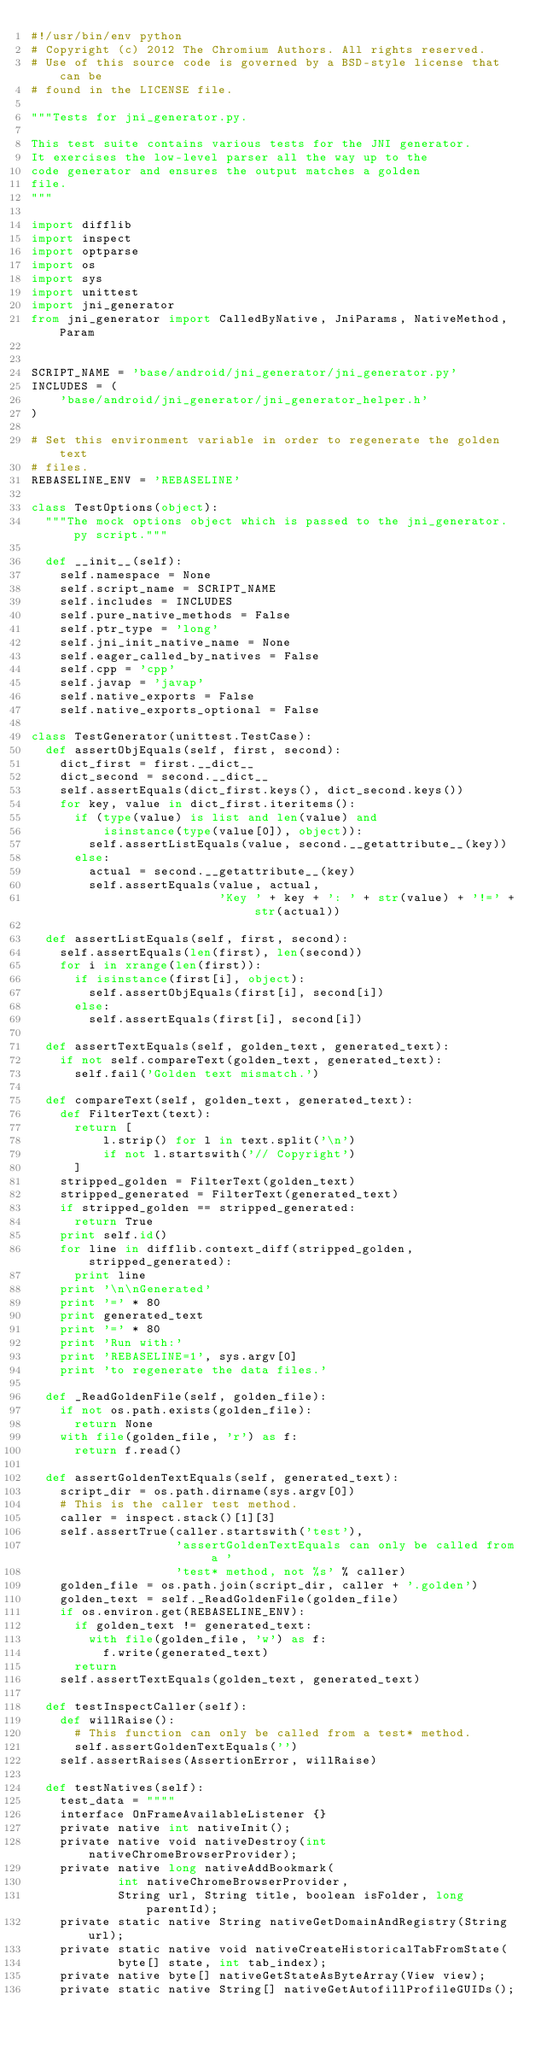Convert code to text. <code><loc_0><loc_0><loc_500><loc_500><_Python_>#!/usr/bin/env python
# Copyright (c) 2012 The Chromium Authors. All rights reserved.
# Use of this source code is governed by a BSD-style license that can be
# found in the LICENSE file.

"""Tests for jni_generator.py.

This test suite contains various tests for the JNI generator.
It exercises the low-level parser all the way up to the
code generator and ensures the output matches a golden
file.
"""

import difflib
import inspect
import optparse
import os
import sys
import unittest
import jni_generator
from jni_generator import CalledByNative, JniParams, NativeMethod, Param


SCRIPT_NAME = 'base/android/jni_generator/jni_generator.py'
INCLUDES = (
    'base/android/jni_generator/jni_generator_helper.h'
)

# Set this environment variable in order to regenerate the golden text
# files.
REBASELINE_ENV = 'REBASELINE'

class TestOptions(object):
  """The mock options object which is passed to the jni_generator.py script."""

  def __init__(self):
    self.namespace = None
    self.script_name = SCRIPT_NAME
    self.includes = INCLUDES
    self.pure_native_methods = False
    self.ptr_type = 'long'
    self.jni_init_native_name = None
    self.eager_called_by_natives = False
    self.cpp = 'cpp'
    self.javap = 'javap'
    self.native_exports = False
    self.native_exports_optional = False

class TestGenerator(unittest.TestCase):
  def assertObjEquals(self, first, second):
    dict_first = first.__dict__
    dict_second = second.__dict__
    self.assertEquals(dict_first.keys(), dict_second.keys())
    for key, value in dict_first.iteritems():
      if (type(value) is list and len(value) and
          isinstance(type(value[0]), object)):
        self.assertListEquals(value, second.__getattribute__(key))
      else:
        actual = second.__getattribute__(key)
        self.assertEquals(value, actual,
                          'Key ' + key + ': ' + str(value) + '!=' + str(actual))

  def assertListEquals(self, first, second):
    self.assertEquals(len(first), len(second))
    for i in xrange(len(first)):
      if isinstance(first[i], object):
        self.assertObjEquals(first[i], second[i])
      else:
        self.assertEquals(first[i], second[i])

  def assertTextEquals(self, golden_text, generated_text):
    if not self.compareText(golden_text, generated_text):
      self.fail('Golden text mismatch.')

  def compareText(self, golden_text, generated_text):
    def FilterText(text):
      return [
          l.strip() for l in text.split('\n')
          if not l.startswith('// Copyright')
      ]
    stripped_golden = FilterText(golden_text)
    stripped_generated = FilterText(generated_text)
    if stripped_golden == stripped_generated:
      return True
    print self.id()
    for line in difflib.context_diff(stripped_golden, stripped_generated):
      print line
    print '\n\nGenerated'
    print '=' * 80
    print generated_text
    print '=' * 80
    print 'Run with:'
    print 'REBASELINE=1', sys.argv[0]
    print 'to regenerate the data files.'

  def _ReadGoldenFile(self, golden_file):
    if not os.path.exists(golden_file):
      return None
    with file(golden_file, 'r') as f:
      return f.read()

  def assertGoldenTextEquals(self, generated_text):
    script_dir = os.path.dirname(sys.argv[0])
    # This is the caller test method.
    caller = inspect.stack()[1][3]
    self.assertTrue(caller.startswith('test'),
                    'assertGoldenTextEquals can only be called from a '
                    'test* method, not %s' % caller)
    golden_file = os.path.join(script_dir, caller + '.golden')
    golden_text = self._ReadGoldenFile(golden_file)
    if os.environ.get(REBASELINE_ENV):
      if golden_text != generated_text:
        with file(golden_file, 'w') as f:
          f.write(generated_text)
      return
    self.assertTextEquals(golden_text, generated_text)

  def testInspectCaller(self):
    def willRaise():
      # This function can only be called from a test* method.
      self.assertGoldenTextEquals('')
    self.assertRaises(AssertionError, willRaise)

  def testNatives(self):
    test_data = """"
    interface OnFrameAvailableListener {}
    private native int nativeInit();
    private native void nativeDestroy(int nativeChromeBrowserProvider);
    private native long nativeAddBookmark(
            int nativeChromeBrowserProvider,
            String url, String title, boolean isFolder, long parentId);
    private static native String nativeGetDomainAndRegistry(String url);
    private static native void nativeCreateHistoricalTabFromState(
            byte[] state, int tab_index);
    private native byte[] nativeGetStateAsByteArray(View view);
    private static native String[] nativeGetAutofillProfileGUIDs();</code> 